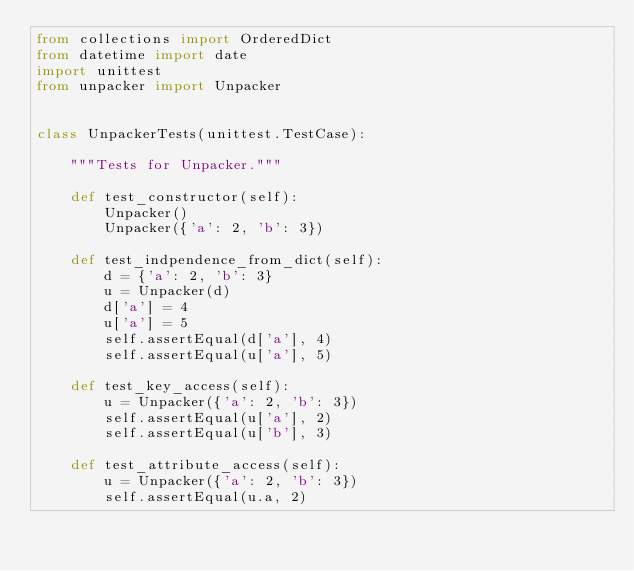Convert code to text. <code><loc_0><loc_0><loc_500><loc_500><_Python_>from collections import OrderedDict
from datetime import date
import unittest
from unpacker import Unpacker


class UnpackerTests(unittest.TestCase):

    """Tests for Unpacker."""

    def test_constructor(self):
        Unpacker()
        Unpacker({'a': 2, 'b': 3})

    def test_indpendence_from_dict(self):
        d = {'a': 2, 'b': 3}
        u = Unpacker(d)
        d['a'] = 4
        u['a'] = 5
        self.assertEqual(d['a'], 4)
        self.assertEqual(u['a'], 5)

    def test_key_access(self):
        u = Unpacker({'a': 2, 'b': 3})
        self.assertEqual(u['a'], 2)
        self.assertEqual(u['b'], 3)

    def test_attribute_access(self):
        u = Unpacker({'a': 2, 'b': 3})
        self.assertEqual(u.a, 2)</code> 